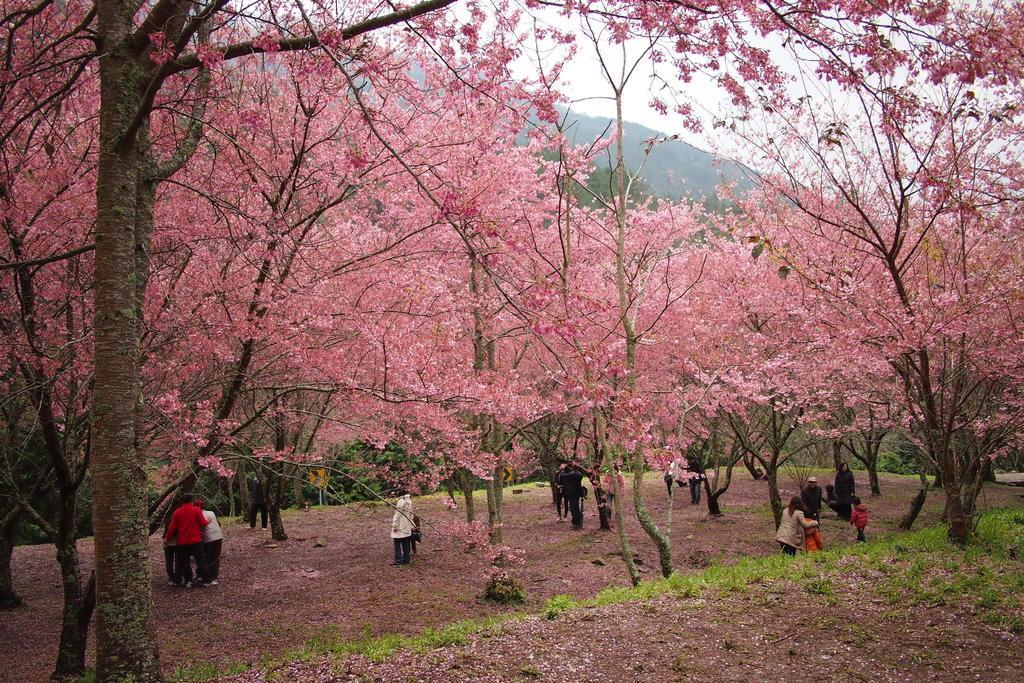Could you give a brief overview of what you see in this image? In this picture, we can see the ground with grass, plants, leaves, and we can see some trees, mountains and the sky. 